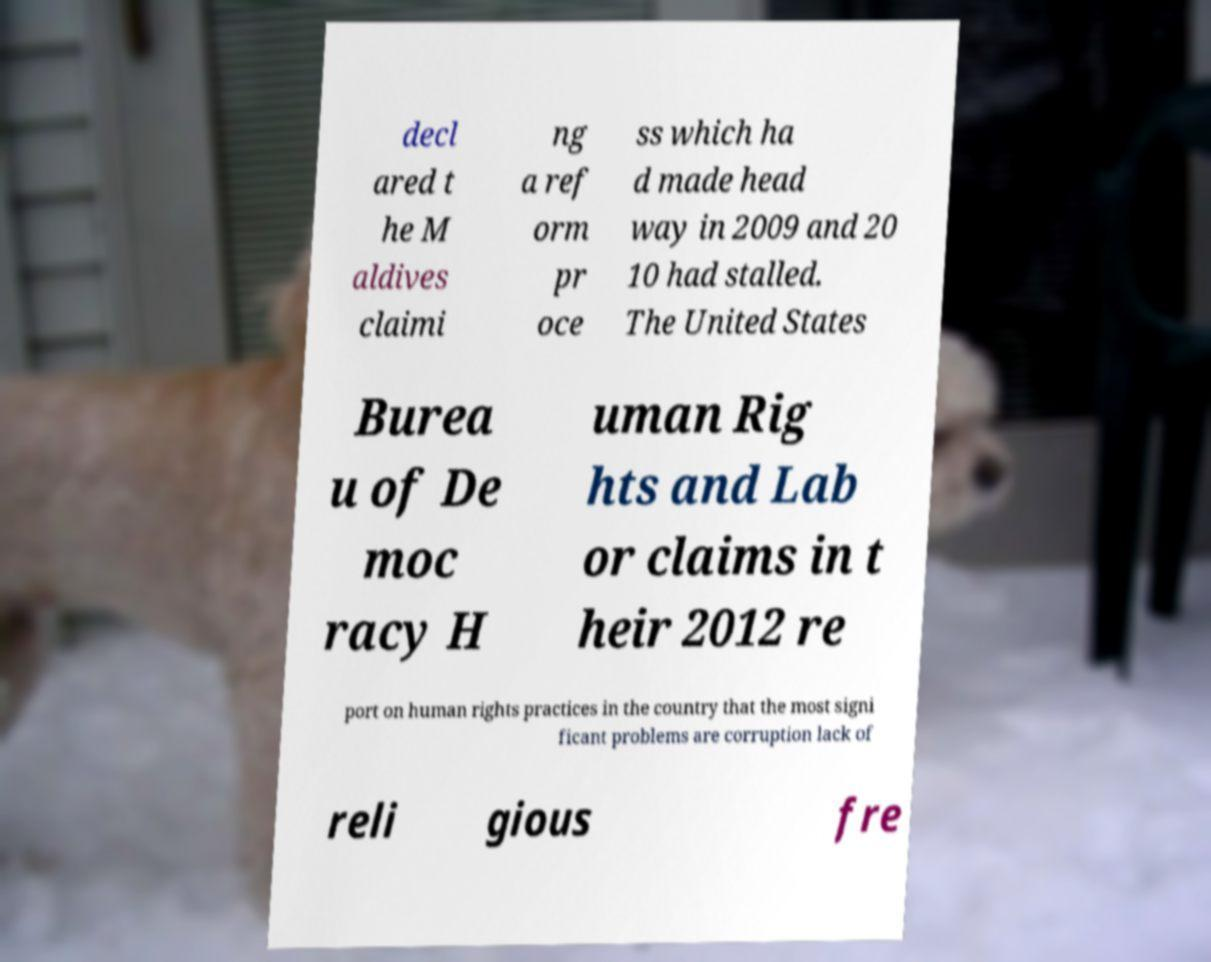I need the written content from this picture converted into text. Can you do that? decl ared t he M aldives claimi ng a ref orm pr oce ss which ha d made head way in 2009 and 20 10 had stalled. The United States Burea u of De moc racy H uman Rig hts and Lab or claims in t heir 2012 re port on human rights practices in the country that the most signi ficant problems are corruption lack of reli gious fre 